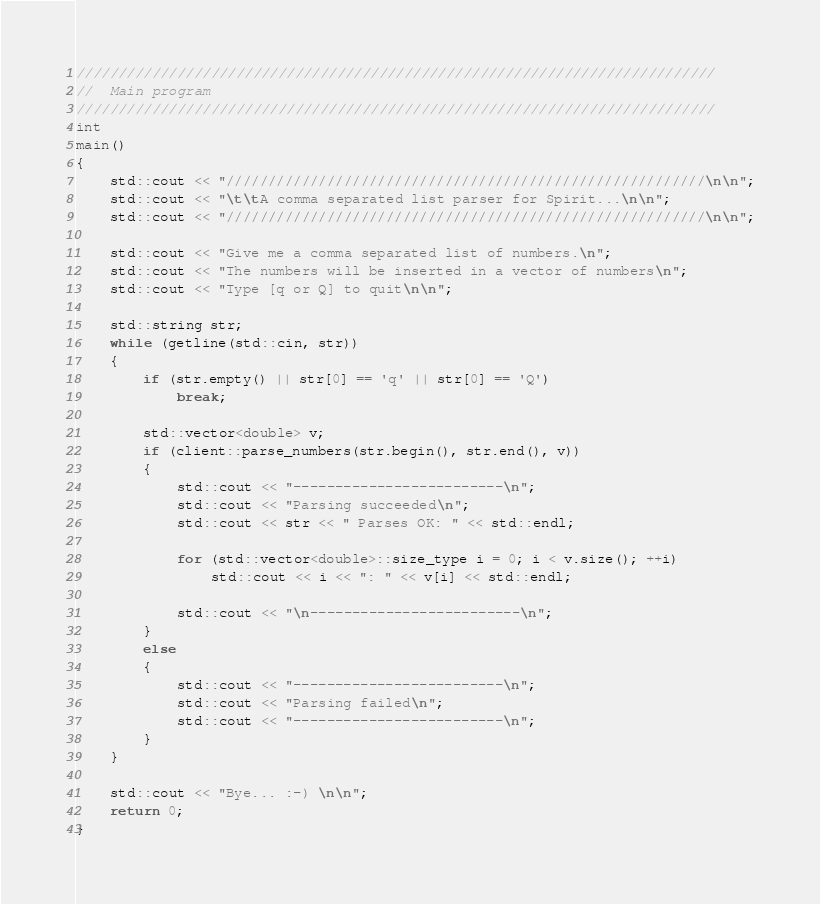Convert code to text. <code><loc_0><loc_0><loc_500><loc_500><_C++_>////////////////////////////////////////////////////////////////////////////
//  Main program
////////////////////////////////////////////////////////////////////////////
int
main()
{
    std::cout << "/////////////////////////////////////////////////////////\n\n";
    std::cout << "\t\tA comma separated list parser for Spirit...\n\n";
    std::cout << "/////////////////////////////////////////////////////////\n\n";

    std::cout << "Give me a comma separated list of numbers.\n";
    std::cout << "The numbers will be inserted in a vector of numbers\n";
    std::cout << "Type [q or Q] to quit\n\n";

    std::string str;
    while (getline(std::cin, str))
    {
        if (str.empty() || str[0] == 'q' || str[0] == 'Q')
            break;

        std::vector<double> v;
        if (client::parse_numbers(str.begin(), str.end(), v))
        {
            std::cout << "-------------------------\n";
            std::cout << "Parsing succeeded\n";
            std::cout << str << " Parses OK: " << std::endl;

            for (std::vector<double>::size_type i = 0; i < v.size(); ++i)
                std::cout << i << ": " << v[i] << std::endl;

            std::cout << "\n-------------------------\n";
        }
        else
        {
            std::cout << "-------------------------\n";
            std::cout << "Parsing failed\n";
            std::cout << "-------------------------\n";
        }
    }

    std::cout << "Bye... :-) \n\n";
    return 0;
}
</code> 